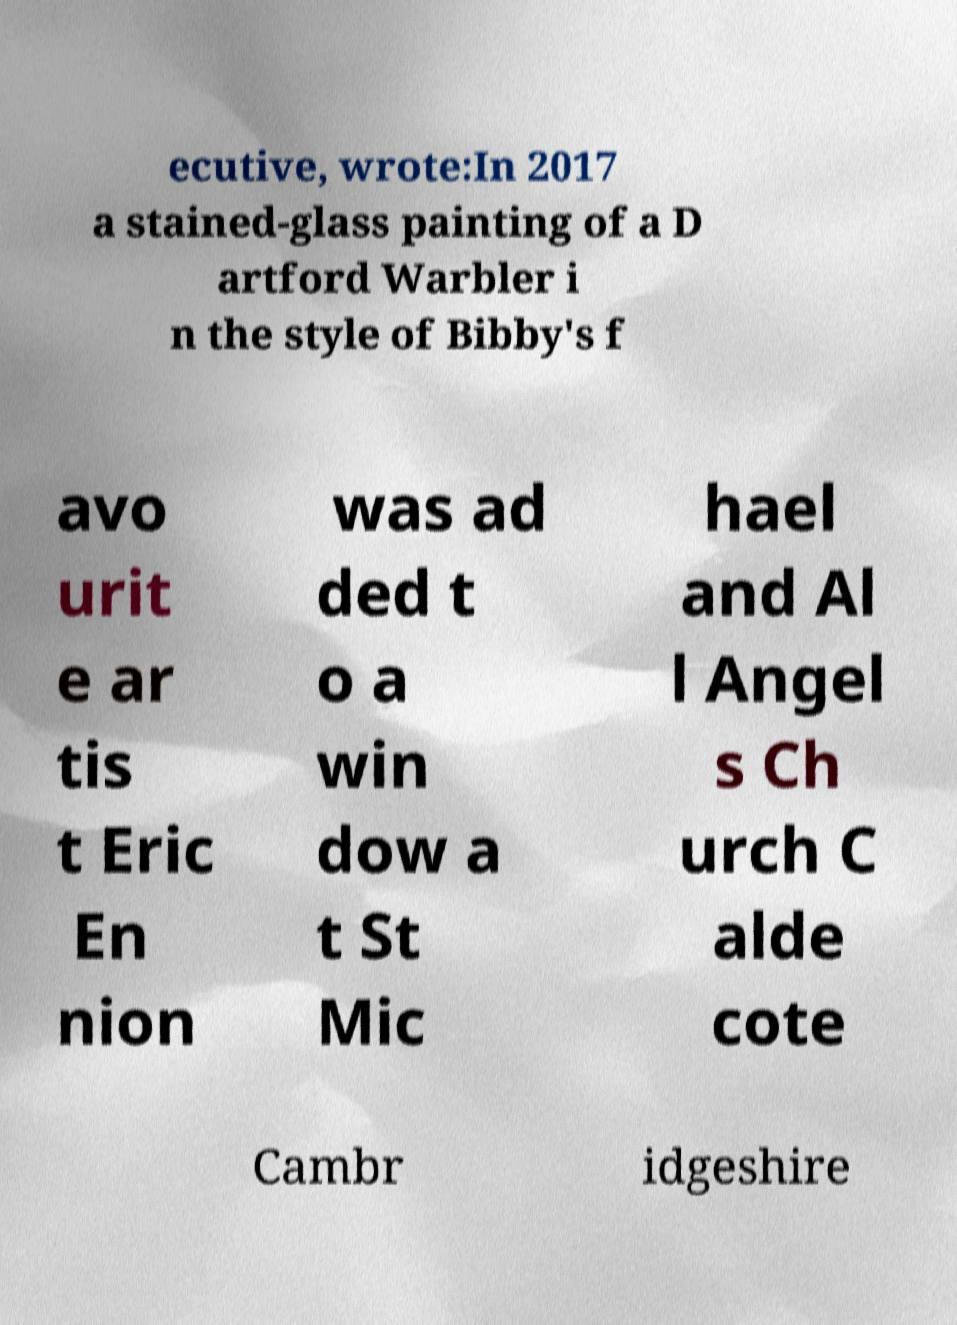Can you accurately transcribe the text from the provided image for me? ecutive, wrote:In 2017 a stained-glass painting of a D artford Warbler i n the style of Bibby's f avo urit e ar tis t Eric En nion was ad ded t o a win dow a t St Mic hael and Al l Angel s Ch urch C alde cote Cambr idgeshire 